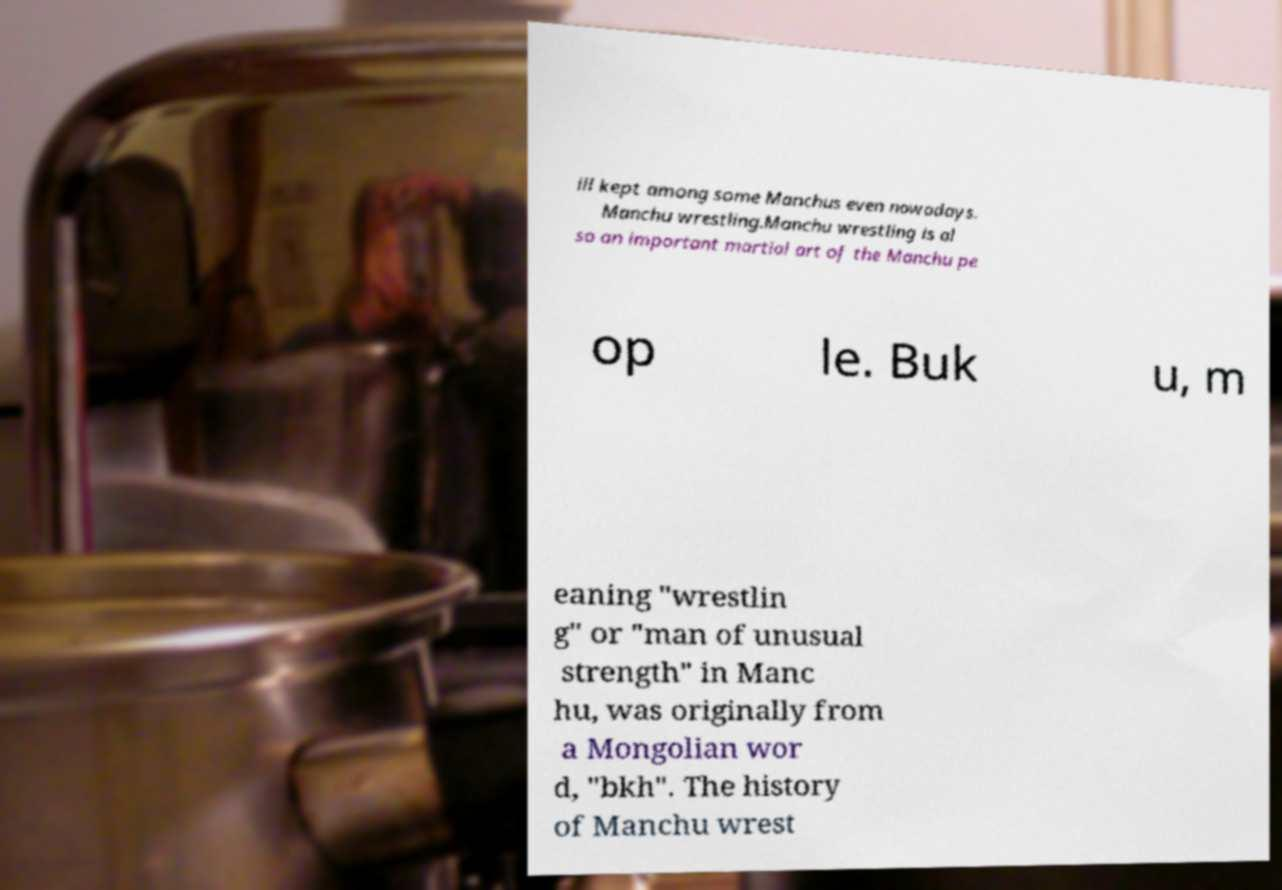What messages or text are displayed in this image? I need them in a readable, typed format. ill kept among some Manchus even nowadays. Manchu wrestling.Manchu wrestling is al so an important martial art of the Manchu pe op le. Buk u, m eaning "wrestlin g" or "man of unusual strength" in Manc hu, was originally from a Mongolian wor d, "bkh". The history of Manchu wrest 